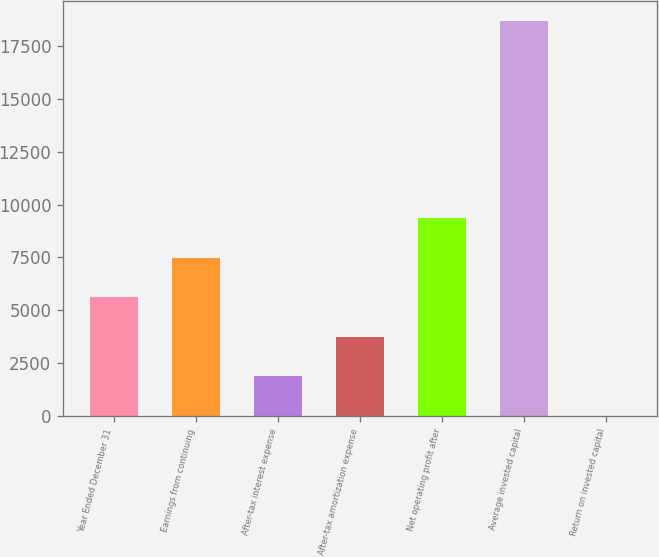Convert chart to OTSL. <chart><loc_0><loc_0><loc_500><loc_500><bar_chart><fcel>Year Ended December 31<fcel>Earnings from continuing<fcel>After-tax interest expense<fcel>After-tax amortization expense<fcel>Net operating profit after<fcel>Average invested capital<fcel>Return on invested capital<nl><fcel>5612.47<fcel>7478.26<fcel>1880.89<fcel>3746.68<fcel>9344.05<fcel>18673<fcel>15.1<nl></chart> 